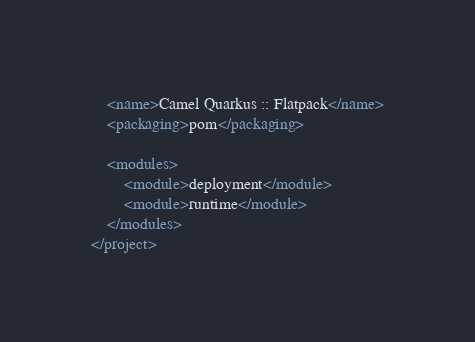<code> <loc_0><loc_0><loc_500><loc_500><_XML_>    <name>Camel Quarkus :: Flatpack</name>
    <packaging>pom</packaging>

    <modules>
        <module>deployment</module>
        <module>runtime</module>
    </modules>
</project>
</code> 